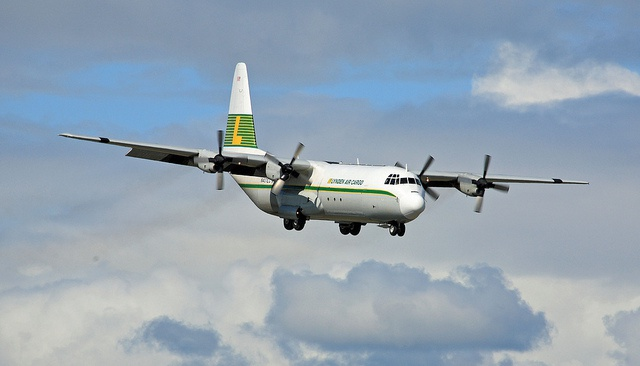Describe the objects in this image and their specific colors. I can see a airplane in gray, darkgray, black, and lightgray tones in this image. 